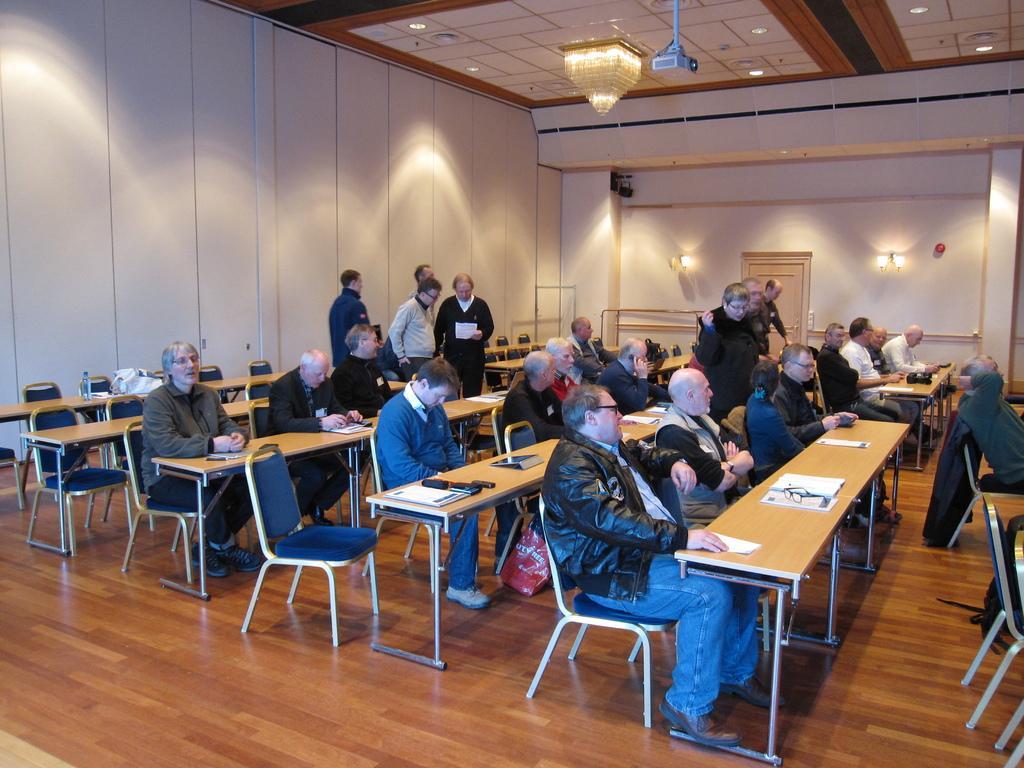In one or two sentences, can you explain what this image depicts? It is look like a conference room. So many peoples are sat on the blue color chair. There are so many tables. At the left side, we can see white color wall. The right side white color wall. Lights are hanging. Here cream color door. At the roof, we can see chandelier, light, projector. On top of table, we can see glass,books, mobile, papers. Few are standing here and here. 